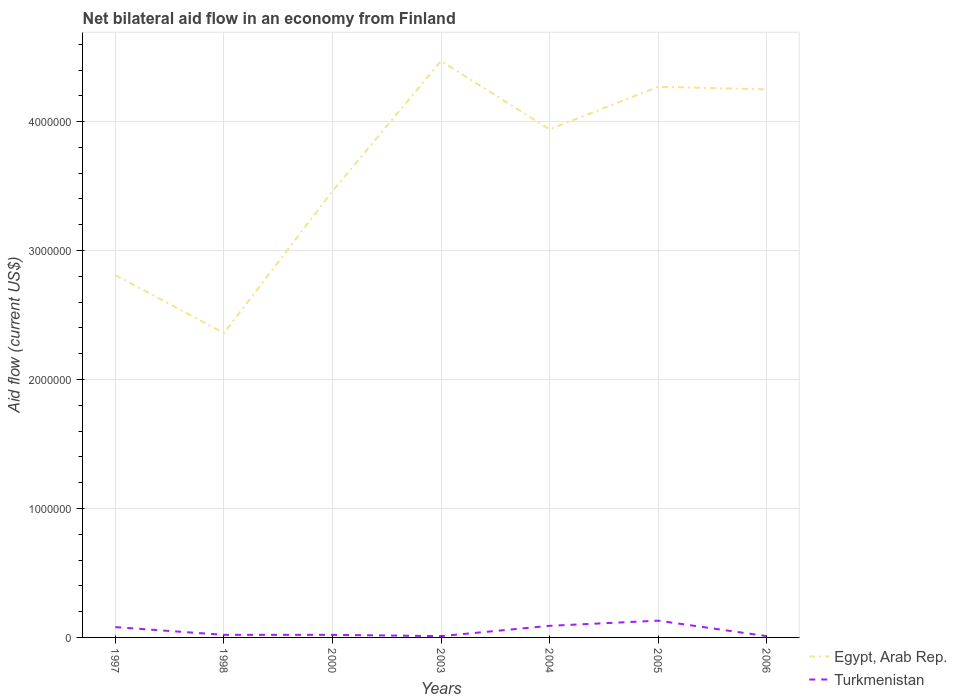How many different coloured lines are there?
Make the answer very short. 2. Is the number of lines equal to the number of legend labels?
Keep it short and to the point. Yes. Across all years, what is the maximum net bilateral aid flow in Turkmenistan?
Provide a short and direct response. 10000. What is the total net bilateral aid flow in Egypt, Arab Rep. in the graph?
Ensure brevity in your answer.  -1.58e+06. Is the net bilateral aid flow in Turkmenistan strictly greater than the net bilateral aid flow in Egypt, Arab Rep. over the years?
Keep it short and to the point. Yes. How many lines are there?
Your response must be concise. 2. How many years are there in the graph?
Provide a succinct answer. 7. What is the difference between two consecutive major ticks on the Y-axis?
Your answer should be compact. 1.00e+06. Does the graph contain grids?
Provide a succinct answer. Yes. Where does the legend appear in the graph?
Provide a succinct answer. Bottom right. How many legend labels are there?
Keep it short and to the point. 2. What is the title of the graph?
Your answer should be very brief. Net bilateral aid flow in an economy from Finland. Does "Solomon Islands" appear as one of the legend labels in the graph?
Provide a succinct answer. No. What is the Aid flow (current US$) in Egypt, Arab Rep. in 1997?
Your response must be concise. 2.81e+06. What is the Aid flow (current US$) in Egypt, Arab Rep. in 1998?
Your answer should be compact. 2.36e+06. What is the Aid flow (current US$) in Turkmenistan in 1998?
Your answer should be very brief. 2.00e+04. What is the Aid flow (current US$) in Egypt, Arab Rep. in 2000?
Your answer should be compact. 3.46e+06. What is the Aid flow (current US$) in Turkmenistan in 2000?
Provide a short and direct response. 2.00e+04. What is the Aid flow (current US$) of Egypt, Arab Rep. in 2003?
Make the answer very short. 4.47e+06. What is the Aid flow (current US$) in Egypt, Arab Rep. in 2004?
Your answer should be very brief. 3.94e+06. What is the Aid flow (current US$) in Turkmenistan in 2004?
Keep it short and to the point. 9.00e+04. What is the Aid flow (current US$) of Egypt, Arab Rep. in 2005?
Your response must be concise. 4.27e+06. What is the Aid flow (current US$) in Egypt, Arab Rep. in 2006?
Your answer should be very brief. 4.25e+06. Across all years, what is the maximum Aid flow (current US$) of Egypt, Arab Rep.?
Ensure brevity in your answer.  4.47e+06. Across all years, what is the maximum Aid flow (current US$) of Turkmenistan?
Give a very brief answer. 1.30e+05. Across all years, what is the minimum Aid flow (current US$) in Egypt, Arab Rep.?
Your answer should be compact. 2.36e+06. What is the total Aid flow (current US$) of Egypt, Arab Rep. in the graph?
Your answer should be compact. 2.56e+07. What is the difference between the Aid flow (current US$) of Turkmenistan in 1997 and that in 1998?
Give a very brief answer. 6.00e+04. What is the difference between the Aid flow (current US$) in Egypt, Arab Rep. in 1997 and that in 2000?
Provide a succinct answer. -6.50e+05. What is the difference between the Aid flow (current US$) in Egypt, Arab Rep. in 1997 and that in 2003?
Provide a succinct answer. -1.66e+06. What is the difference between the Aid flow (current US$) in Egypt, Arab Rep. in 1997 and that in 2004?
Make the answer very short. -1.13e+06. What is the difference between the Aid flow (current US$) in Egypt, Arab Rep. in 1997 and that in 2005?
Your answer should be compact. -1.46e+06. What is the difference between the Aid flow (current US$) of Turkmenistan in 1997 and that in 2005?
Provide a succinct answer. -5.00e+04. What is the difference between the Aid flow (current US$) of Egypt, Arab Rep. in 1997 and that in 2006?
Your response must be concise. -1.44e+06. What is the difference between the Aid flow (current US$) in Turkmenistan in 1997 and that in 2006?
Ensure brevity in your answer.  7.00e+04. What is the difference between the Aid flow (current US$) in Egypt, Arab Rep. in 1998 and that in 2000?
Give a very brief answer. -1.10e+06. What is the difference between the Aid flow (current US$) in Egypt, Arab Rep. in 1998 and that in 2003?
Ensure brevity in your answer.  -2.11e+06. What is the difference between the Aid flow (current US$) of Turkmenistan in 1998 and that in 2003?
Provide a succinct answer. 10000. What is the difference between the Aid flow (current US$) of Egypt, Arab Rep. in 1998 and that in 2004?
Give a very brief answer. -1.58e+06. What is the difference between the Aid flow (current US$) of Turkmenistan in 1998 and that in 2004?
Give a very brief answer. -7.00e+04. What is the difference between the Aid flow (current US$) in Egypt, Arab Rep. in 1998 and that in 2005?
Your response must be concise. -1.91e+06. What is the difference between the Aid flow (current US$) of Turkmenistan in 1998 and that in 2005?
Your answer should be very brief. -1.10e+05. What is the difference between the Aid flow (current US$) of Egypt, Arab Rep. in 1998 and that in 2006?
Your response must be concise. -1.89e+06. What is the difference between the Aid flow (current US$) in Egypt, Arab Rep. in 2000 and that in 2003?
Keep it short and to the point. -1.01e+06. What is the difference between the Aid flow (current US$) of Egypt, Arab Rep. in 2000 and that in 2004?
Keep it short and to the point. -4.80e+05. What is the difference between the Aid flow (current US$) in Turkmenistan in 2000 and that in 2004?
Offer a very short reply. -7.00e+04. What is the difference between the Aid flow (current US$) in Egypt, Arab Rep. in 2000 and that in 2005?
Give a very brief answer. -8.10e+05. What is the difference between the Aid flow (current US$) of Egypt, Arab Rep. in 2000 and that in 2006?
Your response must be concise. -7.90e+05. What is the difference between the Aid flow (current US$) of Turkmenistan in 2000 and that in 2006?
Offer a very short reply. 10000. What is the difference between the Aid flow (current US$) in Egypt, Arab Rep. in 2003 and that in 2004?
Keep it short and to the point. 5.30e+05. What is the difference between the Aid flow (current US$) of Turkmenistan in 2003 and that in 2004?
Your answer should be compact. -8.00e+04. What is the difference between the Aid flow (current US$) in Egypt, Arab Rep. in 2003 and that in 2006?
Provide a succinct answer. 2.20e+05. What is the difference between the Aid flow (current US$) of Egypt, Arab Rep. in 2004 and that in 2005?
Offer a very short reply. -3.30e+05. What is the difference between the Aid flow (current US$) in Egypt, Arab Rep. in 2004 and that in 2006?
Offer a terse response. -3.10e+05. What is the difference between the Aid flow (current US$) of Turkmenistan in 2005 and that in 2006?
Keep it short and to the point. 1.20e+05. What is the difference between the Aid flow (current US$) of Egypt, Arab Rep. in 1997 and the Aid flow (current US$) of Turkmenistan in 1998?
Your answer should be very brief. 2.79e+06. What is the difference between the Aid flow (current US$) of Egypt, Arab Rep. in 1997 and the Aid flow (current US$) of Turkmenistan in 2000?
Offer a very short reply. 2.79e+06. What is the difference between the Aid flow (current US$) of Egypt, Arab Rep. in 1997 and the Aid flow (current US$) of Turkmenistan in 2003?
Your answer should be very brief. 2.80e+06. What is the difference between the Aid flow (current US$) in Egypt, Arab Rep. in 1997 and the Aid flow (current US$) in Turkmenistan in 2004?
Give a very brief answer. 2.72e+06. What is the difference between the Aid flow (current US$) in Egypt, Arab Rep. in 1997 and the Aid flow (current US$) in Turkmenistan in 2005?
Offer a terse response. 2.68e+06. What is the difference between the Aid flow (current US$) in Egypt, Arab Rep. in 1997 and the Aid flow (current US$) in Turkmenistan in 2006?
Provide a succinct answer. 2.80e+06. What is the difference between the Aid flow (current US$) in Egypt, Arab Rep. in 1998 and the Aid flow (current US$) in Turkmenistan in 2000?
Your answer should be compact. 2.34e+06. What is the difference between the Aid flow (current US$) of Egypt, Arab Rep. in 1998 and the Aid flow (current US$) of Turkmenistan in 2003?
Offer a terse response. 2.35e+06. What is the difference between the Aid flow (current US$) in Egypt, Arab Rep. in 1998 and the Aid flow (current US$) in Turkmenistan in 2004?
Your answer should be very brief. 2.27e+06. What is the difference between the Aid flow (current US$) of Egypt, Arab Rep. in 1998 and the Aid flow (current US$) of Turkmenistan in 2005?
Give a very brief answer. 2.23e+06. What is the difference between the Aid flow (current US$) in Egypt, Arab Rep. in 1998 and the Aid flow (current US$) in Turkmenistan in 2006?
Offer a very short reply. 2.35e+06. What is the difference between the Aid flow (current US$) in Egypt, Arab Rep. in 2000 and the Aid flow (current US$) in Turkmenistan in 2003?
Keep it short and to the point. 3.45e+06. What is the difference between the Aid flow (current US$) of Egypt, Arab Rep. in 2000 and the Aid flow (current US$) of Turkmenistan in 2004?
Your answer should be compact. 3.37e+06. What is the difference between the Aid flow (current US$) of Egypt, Arab Rep. in 2000 and the Aid flow (current US$) of Turkmenistan in 2005?
Your answer should be very brief. 3.33e+06. What is the difference between the Aid flow (current US$) of Egypt, Arab Rep. in 2000 and the Aid flow (current US$) of Turkmenistan in 2006?
Provide a succinct answer. 3.45e+06. What is the difference between the Aid flow (current US$) of Egypt, Arab Rep. in 2003 and the Aid flow (current US$) of Turkmenistan in 2004?
Provide a succinct answer. 4.38e+06. What is the difference between the Aid flow (current US$) in Egypt, Arab Rep. in 2003 and the Aid flow (current US$) in Turkmenistan in 2005?
Offer a very short reply. 4.34e+06. What is the difference between the Aid flow (current US$) in Egypt, Arab Rep. in 2003 and the Aid flow (current US$) in Turkmenistan in 2006?
Your response must be concise. 4.46e+06. What is the difference between the Aid flow (current US$) of Egypt, Arab Rep. in 2004 and the Aid flow (current US$) of Turkmenistan in 2005?
Your answer should be very brief. 3.81e+06. What is the difference between the Aid flow (current US$) of Egypt, Arab Rep. in 2004 and the Aid flow (current US$) of Turkmenistan in 2006?
Provide a short and direct response. 3.93e+06. What is the difference between the Aid flow (current US$) of Egypt, Arab Rep. in 2005 and the Aid flow (current US$) of Turkmenistan in 2006?
Your answer should be very brief. 4.26e+06. What is the average Aid flow (current US$) in Egypt, Arab Rep. per year?
Ensure brevity in your answer.  3.65e+06. What is the average Aid flow (current US$) in Turkmenistan per year?
Your answer should be compact. 5.14e+04. In the year 1997, what is the difference between the Aid flow (current US$) of Egypt, Arab Rep. and Aid flow (current US$) of Turkmenistan?
Give a very brief answer. 2.73e+06. In the year 1998, what is the difference between the Aid flow (current US$) in Egypt, Arab Rep. and Aid flow (current US$) in Turkmenistan?
Give a very brief answer. 2.34e+06. In the year 2000, what is the difference between the Aid flow (current US$) of Egypt, Arab Rep. and Aid flow (current US$) of Turkmenistan?
Your answer should be very brief. 3.44e+06. In the year 2003, what is the difference between the Aid flow (current US$) in Egypt, Arab Rep. and Aid flow (current US$) in Turkmenistan?
Ensure brevity in your answer.  4.46e+06. In the year 2004, what is the difference between the Aid flow (current US$) in Egypt, Arab Rep. and Aid flow (current US$) in Turkmenistan?
Your answer should be compact. 3.85e+06. In the year 2005, what is the difference between the Aid flow (current US$) of Egypt, Arab Rep. and Aid flow (current US$) of Turkmenistan?
Ensure brevity in your answer.  4.14e+06. In the year 2006, what is the difference between the Aid flow (current US$) in Egypt, Arab Rep. and Aid flow (current US$) in Turkmenistan?
Offer a terse response. 4.24e+06. What is the ratio of the Aid flow (current US$) of Egypt, Arab Rep. in 1997 to that in 1998?
Your answer should be compact. 1.19. What is the ratio of the Aid flow (current US$) in Turkmenistan in 1997 to that in 1998?
Provide a short and direct response. 4. What is the ratio of the Aid flow (current US$) in Egypt, Arab Rep. in 1997 to that in 2000?
Ensure brevity in your answer.  0.81. What is the ratio of the Aid flow (current US$) of Turkmenistan in 1997 to that in 2000?
Your answer should be compact. 4. What is the ratio of the Aid flow (current US$) of Egypt, Arab Rep. in 1997 to that in 2003?
Make the answer very short. 0.63. What is the ratio of the Aid flow (current US$) in Egypt, Arab Rep. in 1997 to that in 2004?
Your answer should be compact. 0.71. What is the ratio of the Aid flow (current US$) of Egypt, Arab Rep. in 1997 to that in 2005?
Keep it short and to the point. 0.66. What is the ratio of the Aid flow (current US$) of Turkmenistan in 1997 to that in 2005?
Your answer should be very brief. 0.62. What is the ratio of the Aid flow (current US$) of Egypt, Arab Rep. in 1997 to that in 2006?
Offer a terse response. 0.66. What is the ratio of the Aid flow (current US$) of Turkmenistan in 1997 to that in 2006?
Provide a succinct answer. 8. What is the ratio of the Aid flow (current US$) of Egypt, Arab Rep. in 1998 to that in 2000?
Ensure brevity in your answer.  0.68. What is the ratio of the Aid flow (current US$) in Turkmenistan in 1998 to that in 2000?
Give a very brief answer. 1. What is the ratio of the Aid flow (current US$) of Egypt, Arab Rep. in 1998 to that in 2003?
Your response must be concise. 0.53. What is the ratio of the Aid flow (current US$) in Egypt, Arab Rep. in 1998 to that in 2004?
Give a very brief answer. 0.6. What is the ratio of the Aid flow (current US$) in Turkmenistan in 1998 to that in 2004?
Make the answer very short. 0.22. What is the ratio of the Aid flow (current US$) in Egypt, Arab Rep. in 1998 to that in 2005?
Provide a short and direct response. 0.55. What is the ratio of the Aid flow (current US$) of Turkmenistan in 1998 to that in 2005?
Offer a terse response. 0.15. What is the ratio of the Aid flow (current US$) in Egypt, Arab Rep. in 1998 to that in 2006?
Your answer should be very brief. 0.56. What is the ratio of the Aid flow (current US$) of Egypt, Arab Rep. in 2000 to that in 2003?
Offer a terse response. 0.77. What is the ratio of the Aid flow (current US$) of Turkmenistan in 2000 to that in 2003?
Offer a terse response. 2. What is the ratio of the Aid flow (current US$) of Egypt, Arab Rep. in 2000 to that in 2004?
Ensure brevity in your answer.  0.88. What is the ratio of the Aid flow (current US$) in Turkmenistan in 2000 to that in 2004?
Your response must be concise. 0.22. What is the ratio of the Aid flow (current US$) of Egypt, Arab Rep. in 2000 to that in 2005?
Give a very brief answer. 0.81. What is the ratio of the Aid flow (current US$) in Turkmenistan in 2000 to that in 2005?
Offer a very short reply. 0.15. What is the ratio of the Aid flow (current US$) in Egypt, Arab Rep. in 2000 to that in 2006?
Provide a succinct answer. 0.81. What is the ratio of the Aid flow (current US$) of Turkmenistan in 2000 to that in 2006?
Give a very brief answer. 2. What is the ratio of the Aid flow (current US$) of Egypt, Arab Rep. in 2003 to that in 2004?
Your response must be concise. 1.13. What is the ratio of the Aid flow (current US$) of Egypt, Arab Rep. in 2003 to that in 2005?
Your answer should be very brief. 1.05. What is the ratio of the Aid flow (current US$) in Turkmenistan in 2003 to that in 2005?
Provide a short and direct response. 0.08. What is the ratio of the Aid flow (current US$) of Egypt, Arab Rep. in 2003 to that in 2006?
Give a very brief answer. 1.05. What is the ratio of the Aid flow (current US$) in Egypt, Arab Rep. in 2004 to that in 2005?
Keep it short and to the point. 0.92. What is the ratio of the Aid flow (current US$) of Turkmenistan in 2004 to that in 2005?
Give a very brief answer. 0.69. What is the ratio of the Aid flow (current US$) in Egypt, Arab Rep. in 2004 to that in 2006?
Provide a succinct answer. 0.93. What is the ratio of the Aid flow (current US$) of Turkmenistan in 2005 to that in 2006?
Make the answer very short. 13. What is the difference between the highest and the second highest Aid flow (current US$) in Egypt, Arab Rep.?
Your answer should be compact. 2.00e+05. What is the difference between the highest and the lowest Aid flow (current US$) of Egypt, Arab Rep.?
Offer a terse response. 2.11e+06. 